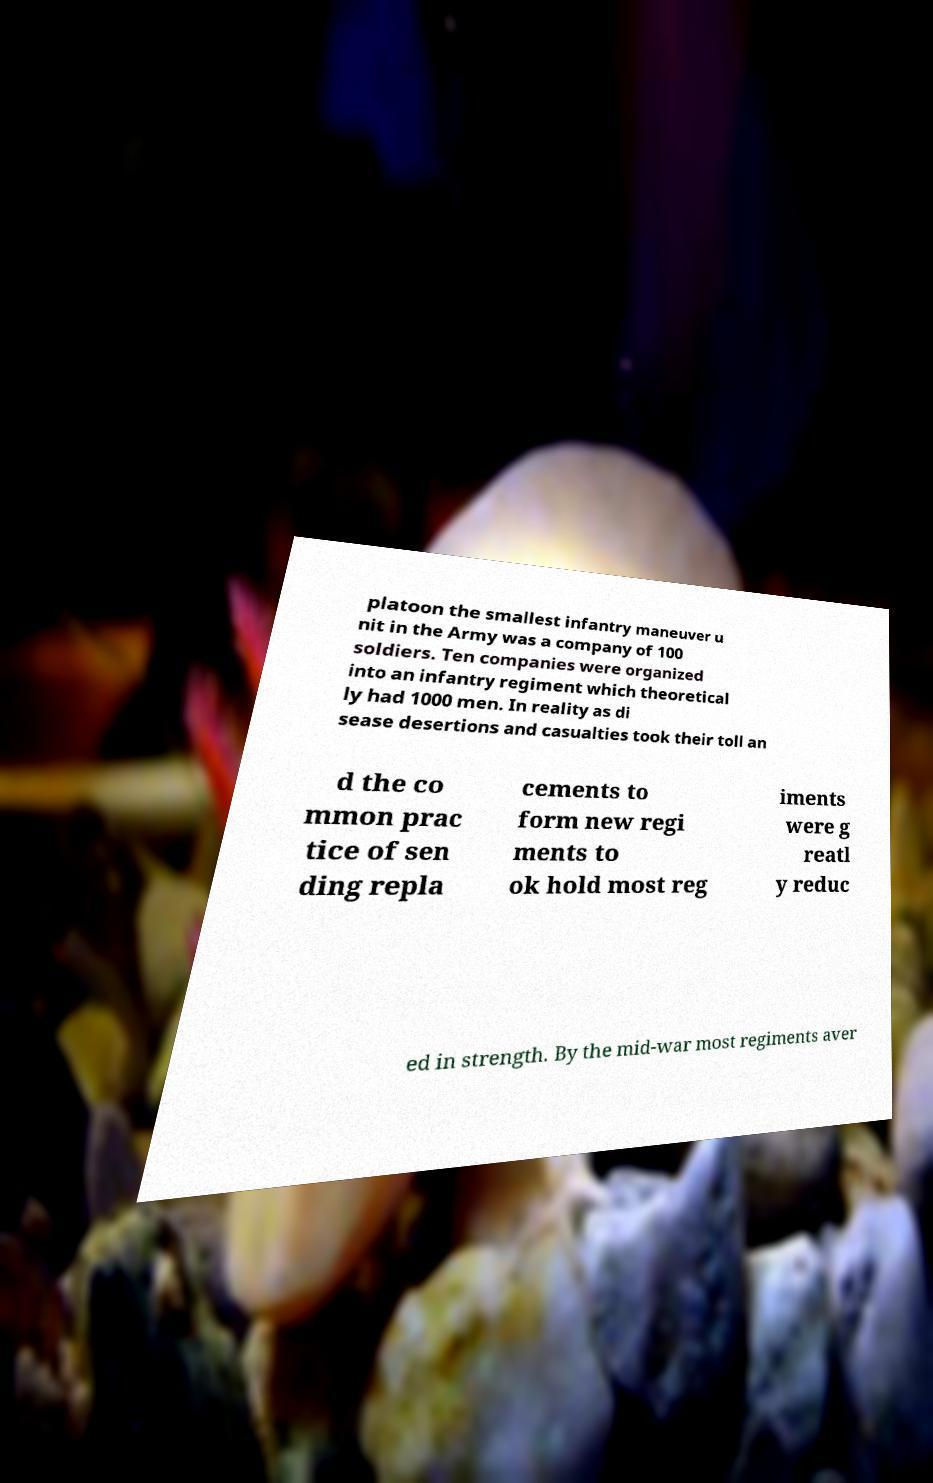Could you assist in decoding the text presented in this image and type it out clearly? platoon the smallest infantry maneuver u nit in the Army was a company of 100 soldiers. Ten companies were organized into an infantry regiment which theoretical ly had 1000 men. In reality as di sease desertions and casualties took their toll an d the co mmon prac tice of sen ding repla cements to form new regi ments to ok hold most reg iments were g reatl y reduc ed in strength. By the mid-war most regiments aver 